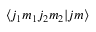Convert formula to latex. <formula><loc_0><loc_0><loc_500><loc_500>\langle j _ { 1 } m _ { 1 } j _ { 2 } m _ { 2 } | j m \rangle</formula> 